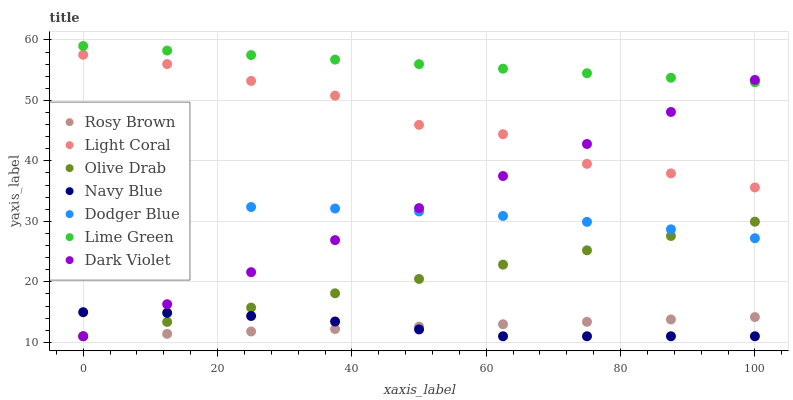Does Rosy Brown have the minimum area under the curve?
Answer yes or no. Yes. Does Lime Green have the maximum area under the curve?
Answer yes or no. Yes. Does Dark Violet have the minimum area under the curve?
Answer yes or no. No. Does Dark Violet have the maximum area under the curve?
Answer yes or no. No. Is Olive Drab the smoothest?
Answer yes or no. Yes. Is Light Coral the roughest?
Answer yes or no. Yes. Is Rosy Brown the smoothest?
Answer yes or no. No. Is Rosy Brown the roughest?
Answer yes or no. No. Does Navy Blue have the lowest value?
Answer yes or no. Yes. Does Light Coral have the lowest value?
Answer yes or no. No. Does Lime Green have the highest value?
Answer yes or no. Yes. Does Dark Violet have the highest value?
Answer yes or no. No. Is Light Coral less than Lime Green?
Answer yes or no. Yes. Is Light Coral greater than Navy Blue?
Answer yes or no. Yes. Does Dodger Blue intersect Olive Drab?
Answer yes or no. Yes. Is Dodger Blue less than Olive Drab?
Answer yes or no. No. Is Dodger Blue greater than Olive Drab?
Answer yes or no. No. Does Light Coral intersect Lime Green?
Answer yes or no. No. 